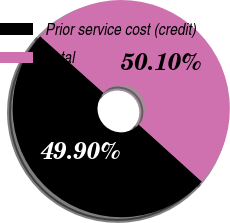<chart> <loc_0><loc_0><loc_500><loc_500><pie_chart><fcel>Prior service cost (credit)<fcel>Total<nl><fcel>49.9%<fcel>50.1%<nl></chart> 